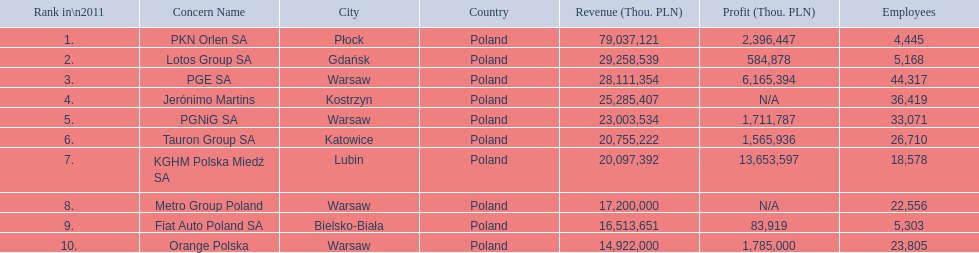What company has 28 111 354 thou.in revenue? PGE SA. What revenue does lotus group sa have? 29 258 539. Could you parse the entire table as a dict? {'header': ['Rank in\\n2011', 'Concern Name', 'City', 'Country', 'Revenue (Thou. PLN)', 'Profit (Thou. PLN)', 'Employees'], 'rows': [['1.', 'PKN Orlen SA', 'Płock', 'Poland', '79,037,121', '2,396,447', '4,445'], ['2.', 'Lotos Group SA', 'Gdańsk', 'Poland', '29,258,539', '584,878', '5,168'], ['3.', 'PGE SA', 'Warsaw', 'Poland', '28,111,354', '6,165,394', '44,317'], ['4.', 'Jerónimo Martins', 'Kostrzyn', 'Poland', '25,285,407', 'N/A', '36,419'], ['5.', 'PGNiG SA', 'Warsaw', 'Poland', '23,003,534', '1,711,787', '33,071'], ['6.', 'Tauron Group SA', 'Katowice', 'Poland', '20,755,222', '1,565,936', '26,710'], ['7.', 'KGHM Polska Miedź SA', 'Lubin', 'Poland', '20,097,392', '13,653,597', '18,578'], ['8.', 'Metro Group Poland', 'Warsaw', 'Poland', '17,200,000', 'N/A', '22,556'], ['9.', 'Fiat Auto Poland SA', 'Bielsko-Biała', 'Poland', '16,513,651', '83,919', '5,303'], ['10.', 'Orange Polska', 'Warsaw', 'Poland', '14,922,000', '1,785,000', '23,805']]} Who has the next highest revenue than lotus group sa? PKN Orlen SA. 